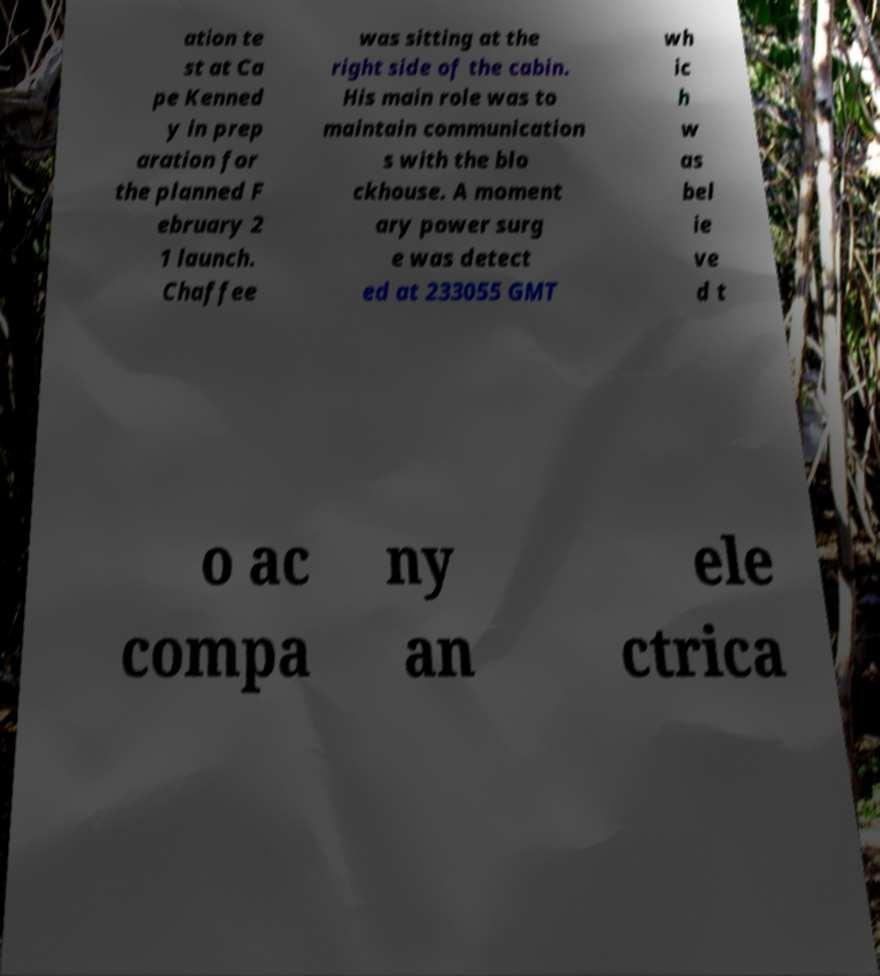I need the written content from this picture converted into text. Can you do that? ation te st at Ca pe Kenned y in prep aration for the planned F ebruary 2 1 launch. Chaffee was sitting at the right side of the cabin. His main role was to maintain communication s with the blo ckhouse. A moment ary power surg e was detect ed at 233055 GMT wh ic h w as bel ie ve d t o ac compa ny an ele ctrica 